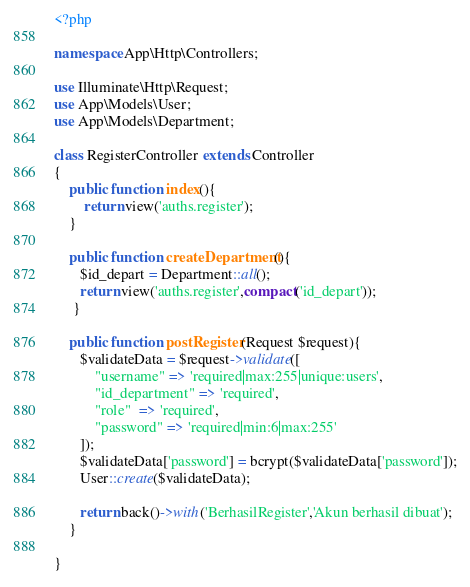<code> <loc_0><loc_0><loc_500><loc_500><_PHP_><?php

namespace App\Http\Controllers;

use Illuminate\Http\Request;
use App\Models\User;
use App\Models\Department;

class RegisterController extends Controller
{
    public function index(){
        return view('auths.register');
    }

    public function createDepartment(){
       $id_depart = Department::all();
       return view('auths.register',compact('id_depart'));
     }
     
    public function postRegister(Request $request){
       $validateData = $request->validate([
           "username" => 'required|max:255|unique:users',
           "id_department" => 'required',
           "role"  => 'required',
           "password" => 'required|min:6|max:255'
       ]);
       $validateData['password'] = bcrypt($validateData['password']);
       User::create($validateData);

       return back()->with('BerhasilRegister','Akun berhasil dibuat');
    }

}
</code> 